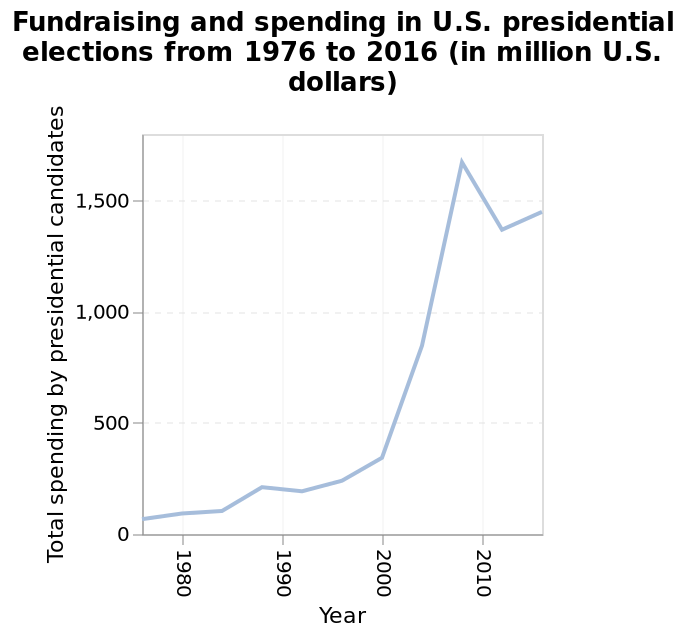<image>
What does the x-axis represent on the line diagram?  The x-axis represents the year in which the U.S. presidential elections were held. What is the time range covered by the line diagram?  The line diagram covers the time period from 1976 to 2016. When did the sharp increase in fundraising and spending start?  This increase started in 2000. please enumerates aspects of the construction of the chart Fundraising and spending in U.S. presidential elections from 1976 to 2016 (in million U.S. dollars) is a line diagram. The y-axis measures Total spending by presidential candidates while the x-axis plots Year. How long did the peak in fundraising and spending last? The duration of the peak in fundraising and spending is not specified in the description. 